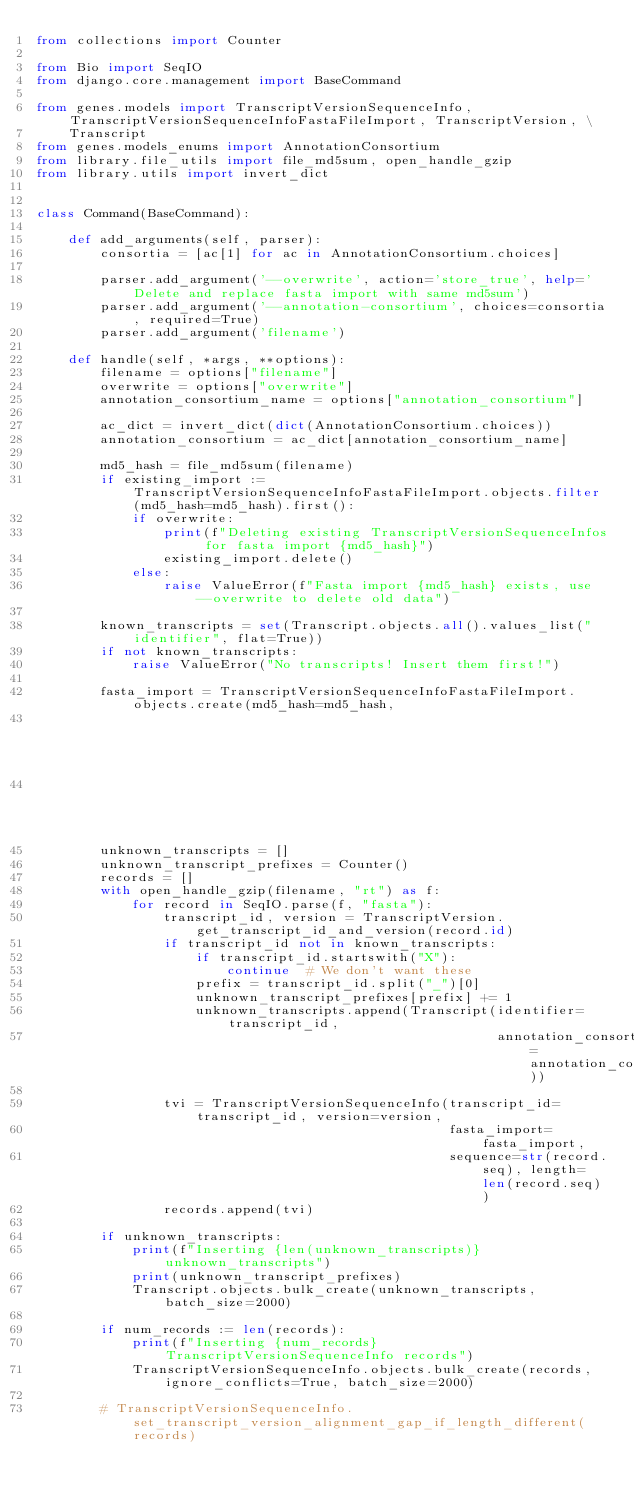Convert code to text. <code><loc_0><loc_0><loc_500><loc_500><_Python_>from collections import Counter

from Bio import SeqIO
from django.core.management import BaseCommand

from genes.models import TranscriptVersionSequenceInfo, TranscriptVersionSequenceInfoFastaFileImport, TranscriptVersion, \
    Transcript
from genes.models_enums import AnnotationConsortium
from library.file_utils import file_md5sum, open_handle_gzip
from library.utils import invert_dict


class Command(BaseCommand):

    def add_arguments(self, parser):
        consortia = [ac[1] for ac in AnnotationConsortium.choices]

        parser.add_argument('--overwrite', action='store_true', help='Delete and replace fasta import with same md5sum')
        parser.add_argument('--annotation-consortium', choices=consortia, required=True)
        parser.add_argument('filename')

    def handle(self, *args, **options):
        filename = options["filename"]
        overwrite = options["overwrite"]
        annotation_consortium_name = options["annotation_consortium"]

        ac_dict = invert_dict(dict(AnnotationConsortium.choices))
        annotation_consortium = ac_dict[annotation_consortium_name]

        md5_hash = file_md5sum(filename)
        if existing_import := TranscriptVersionSequenceInfoFastaFileImport.objects.filter(md5_hash=md5_hash).first():
            if overwrite:
                print(f"Deleting existing TranscriptVersionSequenceInfos for fasta import {md5_hash}")
                existing_import.delete()
            else:
                raise ValueError(f"Fasta import {md5_hash} exists, use --overwrite to delete old data")

        known_transcripts = set(Transcript.objects.all().values_list("identifier", flat=True))
        if not known_transcripts:
            raise ValueError("No transcripts! Insert them first!")

        fasta_import = TranscriptVersionSequenceInfoFastaFileImport.objects.create(md5_hash=md5_hash,
                                                                                   annotation_consortium=annotation_consortium,
                                                                                   filename=filename)
        unknown_transcripts = []
        unknown_transcript_prefixes = Counter()
        records = []
        with open_handle_gzip(filename, "rt") as f:
            for record in SeqIO.parse(f, "fasta"):
                transcript_id, version = TranscriptVersion.get_transcript_id_and_version(record.id)
                if transcript_id not in known_transcripts:
                    if transcript_id.startswith("X"):
                        continue  # We don't want these
                    prefix = transcript_id.split("_")[0]
                    unknown_transcript_prefixes[prefix] += 1
                    unknown_transcripts.append(Transcript(identifier=transcript_id,
                                                          annotation_consortium=annotation_consortium))

                tvi = TranscriptVersionSequenceInfo(transcript_id=transcript_id, version=version,
                                                    fasta_import=fasta_import,
                                                    sequence=str(record.seq), length=len(record.seq))
                records.append(tvi)

        if unknown_transcripts:
            print(f"Inserting {len(unknown_transcripts)} unknown_transcripts")
            print(unknown_transcript_prefixes)
            Transcript.objects.bulk_create(unknown_transcripts, batch_size=2000)

        if num_records := len(records):
            print(f"Inserting {num_records} TranscriptVersionSequenceInfo records")
            TranscriptVersionSequenceInfo.objects.bulk_create(records, ignore_conflicts=True, batch_size=2000)

        # TranscriptVersionSequenceInfo.set_transcript_version_alignment_gap_if_length_different(records)
</code> 